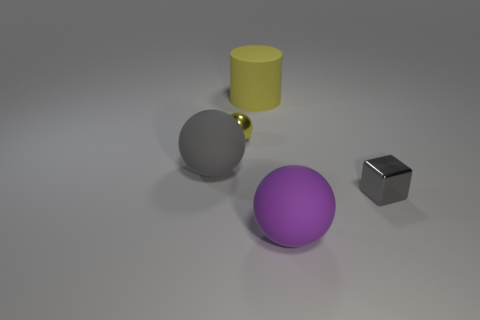What materials might these objects be made of given their appearance? Judging by their appearance, the purple and gray objects have a matte finish that might suggest they are made of a surface like plastic or rubber, giving them a non-reflective quality. The small shiny yellow sphere looks metallic due to its reflective surface, and the small black cube might be made of plastic or metal, but it's hard to determine the exact material from the image alone. 